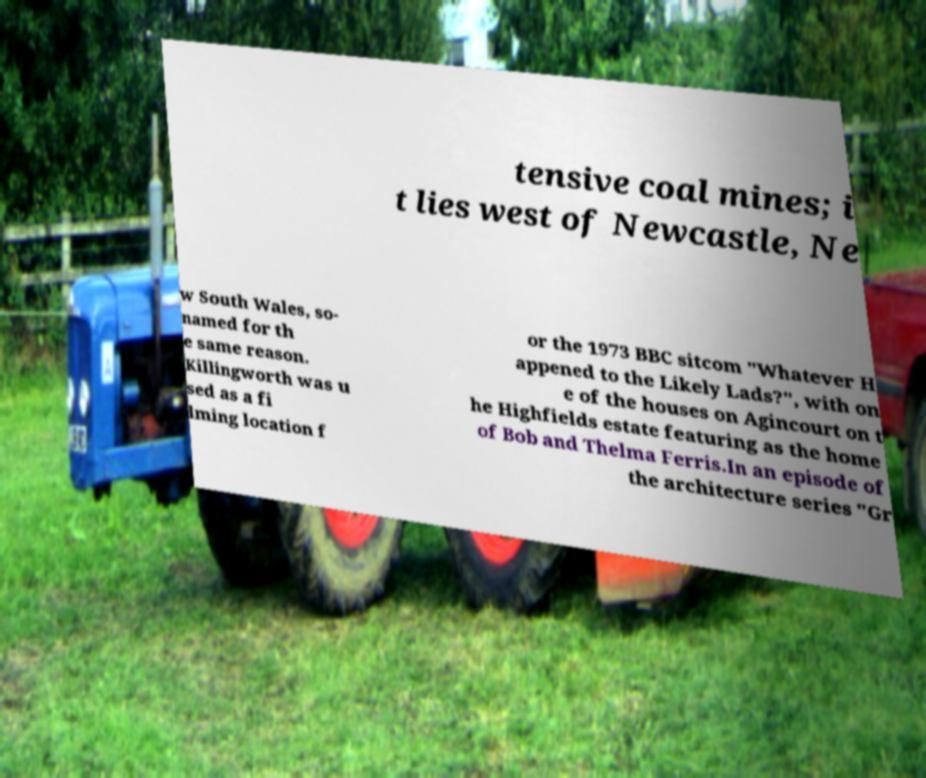For documentation purposes, I need the text within this image transcribed. Could you provide that? tensive coal mines; i t lies west of Newcastle, Ne w South Wales, so- named for th e same reason. Killingworth was u sed as a fi lming location f or the 1973 BBC sitcom "Whatever H appened to the Likely Lads?", with on e of the houses on Agincourt on t he Highfields estate featuring as the home of Bob and Thelma Ferris.In an episode of the architecture series "Gr 